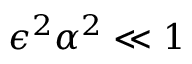<formula> <loc_0><loc_0><loc_500><loc_500>{ \epsilon ^ { 2 } { \alpha } ^ { 2 } } \ll 1</formula> 